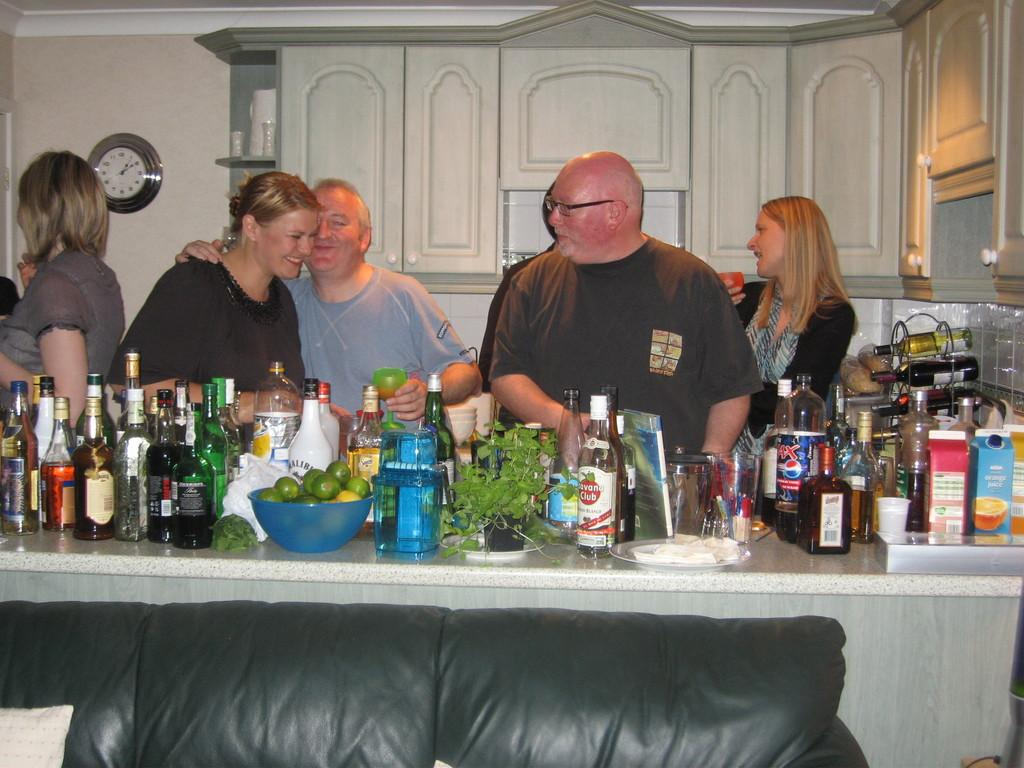<image>
Render a clear and concise summary of the photo. Carton of ASDA orange juice and a bottle of malibu alcohol. 